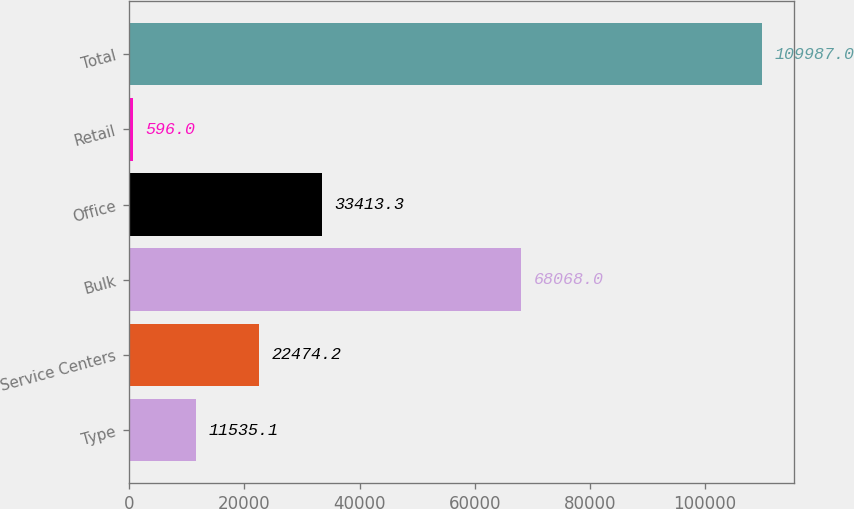Convert chart. <chart><loc_0><loc_0><loc_500><loc_500><bar_chart><fcel>Type<fcel>Service Centers<fcel>Bulk<fcel>Office<fcel>Retail<fcel>Total<nl><fcel>11535.1<fcel>22474.2<fcel>68068<fcel>33413.3<fcel>596<fcel>109987<nl></chart> 